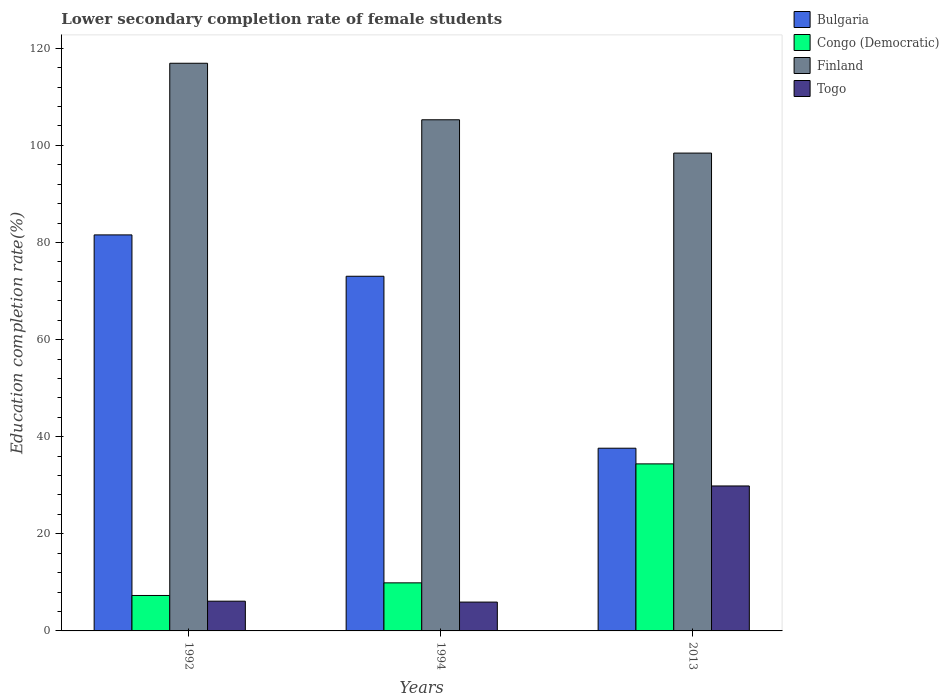How many groups of bars are there?
Provide a short and direct response. 3. Are the number of bars per tick equal to the number of legend labels?
Keep it short and to the point. Yes. Are the number of bars on each tick of the X-axis equal?
Your response must be concise. Yes. How many bars are there on the 3rd tick from the left?
Make the answer very short. 4. How many bars are there on the 2nd tick from the right?
Provide a succinct answer. 4. What is the label of the 1st group of bars from the left?
Provide a short and direct response. 1992. What is the lower secondary completion rate of female students in Togo in 1992?
Your response must be concise. 6.13. Across all years, what is the maximum lower secondary completion rate of female students in Bulgaria?
Provide a succinct answer. 81.56. Across all years, what is the minimum lower secondary completion rate of female students in Togo?
Keep it short and to the point. 5.94. In which year was the lower secondary completion rate of female students in Togo maximum?
Provide a short and direct response. 2013. In which year was the lower secondary completion rate of female students in Finland minimum?
Keep it short and to the point. 2013. What is the total lower secondary completion rate of female students in Bulgaria in the graph?
Ensure brevity in your answer.  192.23. What is the difference between the lower secondary completion rate of female students in Finland in 1992 and that in 2013?
Your response must be concise. 18.5. What is the difference between the lower secondary completion rate of female students in Togo in 1992 and the lower secondary completion rate of female students in Congo (Democratic) in 2013?
Offer a very short reply. -28.28. What is the average lower secondary completion rate of female students in Congo (Democratic) per year?
Your response must be concise. 17.2. In the year 2013, what is the difference between the lower secondary completion rate of female students in Finland and lower secondary completion rate of female students in Congo (Democratic)?
Ensure brevity in your answer.  64.01. What is the ratio of the lower secondary completion rate of female students in Finland in 1994 to that in 2013?
Provide a short and direct response. 1.07. Is the difference between the lower secondary completion rate of female students in Finland in 1992 and 1994 greater than the difference between the lower secondary completion rate of female students in Congo (Democratic) in 1992 and 1994?
Provide a succinct answer. Yes. What is the difference between the highest and the second highest lower secondary completion rate of female students in Finland?
Give a very brief answer. 11.64. What is the difference between the highest and the lowest lower secondary completion rate of female students in Bulgaria?
Your answer should be very brief. 43.93. What does the 3rd bar from the right in 1992 represents?
Keep it short and to the point. Congo (Democratic). What is the difference between two consecutive major ticks on the Y-axis?
Keep it short and to the point. 20. Does the graph contain grids?
Offer a very short reply. No. Where does the legend appear in the graph?
Ensure brevity in your answer.  Top right. What is the title of the graph?
Make the answer very short. Lower secondary completion rate of female students. What is the label or title of the X-axis?
Ensure brevity in your answer.  Years. What is the label or title of the Y-axis?
Ensure brevity in your answer.  Education completion rate(%). What is the Education completion rate(%) of Bulgaria in 1992?
Offer a terse response. 81.56. What is the Education completion rate(%) of Congo (Democratic) in 1992?
Offer a terse response. 7.3. What is the Education completion rate(%) in Finland in 1992?
Your answer should be compact. 116.91. What is the Education completion rate(%) of Togo in 1992?
Provide a succinct answer. 6.13. What is the Education completion rate(%) of Bulgaria in 1994?
Give a very brief answer. 73.04. What is the Education completion rate(%) in Congo (Democratic) in 1994?
Offer a very short reply. 9.9. What is the Education completion rate(%) of Finland in 1994?
Ensure brevity in your answer.  105.27. What is the Education completion rate(%) in Togo in 1994?
Give a very brief answer. 5.94. What is the Education completion rate(%) of Bulgaria in 2013?
Provide a short and direct response. 37.63. What is the Education completion rate(%) of Congo (Democratic) in 2013?
Make the answer very short. 34.4. What is the Education completion rate(%) in Finland in 2013?
Provide a short and direct response. 98.41. What is the Education completion rate(%) of Togo in 2013?
Offer a terse response. 29.85. Across all years, what is the maximum Education completion rate(%) of Bulgaria?
Offer a very short reply. 81.56. Across all years, what is the maximum Education completion rate(%) of Congo (Democratic)?
Provide a short and direct response. 34.4. Across all years, what is the maximum Education completion rate(%) of Finland?
Your answer should be compact. 116.91. Across all years, what is the maximum Education completion rate(%) in Togo?
Offer a very short reply. 29.85. Across all years, what is the minimum Education completion rate(%) of Bulgaria?
Your response must be concise. 37.63. Across all years, what is the minimum Education completion rate(%) in Congo (Democratic)?
Provide a succinct answer. 7.3. Across all years, what is the minimum Education completion rate(%) of Finland?
Provide a short and direct response. 98.41. Across all years, what is the minimum Education completion rate(%) in Togo?
Offer a very short reply. 5.94. What is the total Education completion rate(%) in Bulgaria in the graph?
Provide a succinct answer. 192.23. What is the total Education completion rate(%) of Congo (Democratic) in the graph?
Ensure brevity in your answer.  51.6. What is the total Education completion rate(%) in Finland in the graph?
Your answer should be compact. 320.58. What is the total Education completion rate(%) of Togo in the graph?
Provide a succinct answer. 41.92. What is the difference between the Education completion rate(%) of Bulgaria in 1992 and that in 1994?
Your answer should be compact. 8.52. What is the difference between the Education completion rate(%) of Congo (Democratic) in 1992 and that in 1994?
Your answer should be compact. -2.6. What is the difference between the Education completion rate(%) of Finland in 1992 and that in 1994?
Offer a terse response. 11.64. What is the difference between the Education completion rate(%) of Togo in 1992 and that in 1994?
Your answer should be compact. 0.19. What is the difference between the Education completion rate(%) in Bulgaria in 1992 and that in 2013?
Your answer should be very brief. 43.93. What is the difference between the Education completion rate(%) in Congo (Democratic) in 1992 and that in 2013?
Offer a very short reply. -27.1. What is the difference between the Education completion rate(%) in Togo in 1992 and that in 2013?
Provide a short and direct response. -23.73. What is the difference between the Education completion rate(%) of Bulgaria in 1994 and that in 2013?
Give a very brief answer. 35.41. What is the difference between the Education completion rate(%) in Congo (Democratic) in 1994 and that in 2013?
Provide a short and direct response. -24.5. What is the difference between the Education completion rate(%) of Finland in 1994 and that in 2013?
Ensure brevity in your answer.  6.86. What is the difference between the Education completion rate(%) of Togo in 1994 and that in 2013?
Your answer should be very brief. -23.91. What is the difference between the Education completion rate(%) in Bulgaria in 1992 and the Education completion rate(%) in Congo (Democratic) in 1994?
Offer a terse response. 71.66. What is the difference between the Education completion rate(%) of Bulgaria in 1992 and the Education completion rate(%) of Finland in 1994?
Ensure brevity in your answer.  -23.71. What is the difference between the Education completion rate(%) of Bulgaria in 1992 and the Education completion rate(%) of Togo in 1994?
Your answer should be compact. 75.62. What is the difference between the Education completion rate(%) of Congo (Democratic) in 1992 and the Education completion rate(%) of Finland in 1994?
Your answer should be compact. -97.97. What is the difference between the Education completion rate(%) in Congo (Democratic) in 1992 and the Education completion rate(%) in Togo in 1994?
Offer a very short reply. 1.36. What is the difference between the Education completion rate(%) of Finland in 1992 and the Education completion rate(%) of Togo in 1994?
Your response must be concise. 110.97. What is the difference between the Education completion rate(%) of Bulgaria in 1992 and the Education completion rate(%) of Congo (Democratic) in 2013?
Provide a short and direct response. 47.16. What is the difference between the Education completion rate(%) of Bulgaria in 1992 and the Education completion rate(%) of Finland in 2013?
Give a very brief answer. -16.85. What is the difference between the Education completion rate(%) of Bulgaria in 1992 and the Education completion rate(%) of Togo in 2013?
Make the answer very short. 51.71. What is the difference between the Education completion rate(%) in Congo (Democratic) in 1992 and the Education completion rate(%) in Finland in 2013?
Offer a terse response. -91.11. What is the difference between the Education completion rate(%) of Congo (Democratic) in 1992 and the Education completion rate(%) of Togo in 2013?
Provide a short and direct response. -22.55. What is the difference between the Education completion rate(%) of Finland in 1992 and the Education completion rate(%) of Togo in 2013?
Provide a short and direct response. 87.05. What is the difference between the Education completion rate(%) in Bulgaria in 1994 and the Education completion rate(%) in Congo (Democratic) in 2013?
Give a very brief answer. 38.64. What is the difference between the Education completion rate(%) of Bulgaria in 1994 and the Education completion rate(%) of Finland in 2013?
Offer a terse response. -25.36. What is the difference between the Education completion rate(%) of Bulgaria in 1994 and the Education completion rate(%) of Togo in 2013?
Your answer should be very brief. 43.19. What is the difference between the Education completion rate(%) of Congo (Democratic) in 1994 and the Education completion rate(%) of Finland in 2013?
Provide a succinct answer. -88.51. What is the difference between the Education completion rate(%) in Congo (Democratic) in 1994 and the Education completion rate(%) in Togo in 2013?
Your response must be concise. -19.95. What is the difference between the Education completion rate(%) of Finland in 1994 and the Education completion rate(%) of Togo in 2013?
Your answer should be very brief. 75.41. What is the average Education completion rate(%) in Bulgaria per year?
Provide a short and direct response. 64.08. What is the average Education completion rate(%) of Finland per year?
Ensure brevity in your answer.  106.86. What is the average Education completion rate(%) of Togo per year?
Your answer should be very brief. 13.97. In the year 1992, what is the difference between the Education completion rate(%) in Bulgaria and Education completion rate(%) in Congo (Democratic)?
Provide a succinct answer. 74.26. In the year 1992, what is the difference between the Education completion rate(%) in Bulgaria and Education completion rate(%) in Finland?
Your answer should be compact. -35.35. In the year 1992, what is the difference between the Education completion rate(%) of Bulgaria and Education completion rate(%) of Togo?
Make the answer very short. 75.43. In the year 1992, what is the difference between the Education completion rate(%) of Congo (Democratic) and Education completion rate(%) of Finland?
Give a very brief answer. -109.61. In the year 1992, what is the difference between the Education completion rate(%) of Congo (Democratic) and Education completion rate(%) of Togo?
Ensure brevity in your answer.  1.17. In the year 1992, what is the difference between the Education completion rate(%) of Finland and Education completion rate(%) of Togo?
Offer a terse response. 110.78. In the year 1994, what is the difference between the Education completion rate(%) in Bulgaria and Education completion rate(%) in Congo (Democratic)?
Offer a terse response. 63.14. In the year 1994, what is the difference between the Education completion rate(%) of Bulgaria and Education completion rate(%) of Finland?
Your answer should be very brief. -32.22. In the year 1994, what is the difference between the Education completion rate(%) of Bulgaria and Education completion rate(%) of Togo?
Offer a terse response. 67.1. In the year 1994, what is the difference between the Education completion rate(%) of Congo (Democratic) and Education completion rate(%) of Finland?
Provide a succinct answer. -95.37. In the year 1994, what is the difference between the Education completion rate(%) of Congo (Democratic) and Education completion rate(%) of Togo?
Provide a short and direct response. 3.96. In the year 1994, what is the difference between the Education completion rate(%) in Finland and Education completion rate(%) in Togo?
Offer a very short reply. 99.33. In the year 2013, what is the difference between the Education completion rate(%) in Bulgaria and Education completion rate(%) in Congo (Democratic)?
Offer a terse response. 3.23. In the year 2013, what is the difference between the Education completion rate(%) in Bulgaria and Education completion rate(%) in Finland?
Your answer should be compact. -60.78. In the year 2013, what is the difference between the Education completion rate(%) of Bulgaria and Education completion rate(%) of Togo?
Offer a very short reply. 7.77. In the year 2013, what is the difference between the Education completion rate(%) of Congo (Democratic) and Education completion rate(%) of Finland?
Provide a succinct answer. -64. In the year 2013, what is the difference between the Education completion rate(%) in Congo (Democratic) and Education completion rate(%) in Togo?
Your answer should be compact. 4.55. In the year 2013, what is the difference between the Education completion rate(%) in Finland and Education completion rate(%) in Togo?
Offer a terse response. 68.55. What is the ratio of the Education completion rate(%) in Bulgaria in 1992 to that in 1994?
Provide a succinct answer. 1.12. What is the ratio of the Education completion rate(%) of Congo (Democratic) in 1992 to that in 1994?
Ensure brevity in your answer.  0.74. What is the ratio of the Education completion rate(%) of Finland in 1992 to that in 1994?
Make the answer very short. 1.11. What is the ratio of the Education completion rate(%) in Togo in 1992 to that in 1994?
Your response must be concise. 1.03. What is the ratio of the Education completion rate(%) of Bulgaria in 1992 to that in 2013?
Your answer should be very brief. 2.17. What is the ratio of the Education completion rate(%) in Congo (Democratic) in 1992 to that in 2013?
Ensure brevity in your answer.  0.21. What is the ratio of the Education completion rate(%) of Finland in 1992 to that in 2013?
Your answer should be very brief. 1.19. What is the ratio of the Education completion rate(%) of Togo in 1992 to that in 2013?
Give a very brief answer. 0.21. What is the ratio of the Education completion rate(%) in Bulgaria in 1994 to that in 2013?
Ensure brevity in your answer.  1.94. What is the ratio of the Education completion rate(%) of Congo (Democratic) in 1994 to that in 2013?
Your answer should be compact. 0.29. What is the ratio of the Education completion rate(%) of Finland in 1994 to that in 2013?
Your answer should be compact. 1.07. What is the ratio of the Education completion rate(%) in Togo in 1994 to that in 2013?
Your response must be concise. 0.2. What is the difference between the highest and the second highest Education completion rate(%) in Bulgaria?
Offer a terse response. 8.52. What is the difference between the highest and the second highest Education completion rate(%) in Congo (Democratic)?
Keep it short and to the point. 24.5. What is the difference between the highest and the second highest Education completion rate(%) of Finland?
Your response must be concise. 11.64. What is the difference between the highest and the second highest Education completion rate(%) in Togo?
Offer a very short reply. 23.73. What is the difference between the highest and the lowest Education completion rate(%) of Bulgaria?
Your answer should be compact. 43.93. What is the difference between the highest and the lowest Education completion rate(%) of Congo (Democratic)?
Ensure brevity in your answer.  27.1. What is the difference between the highest and the lowest Education completion rate(%) in Finland?
Provide a short and direct response. 18.5. What is the difference between the highest and the lowest Education completion rate(%) of Togo?
Your answer should be compact. 23.91. 